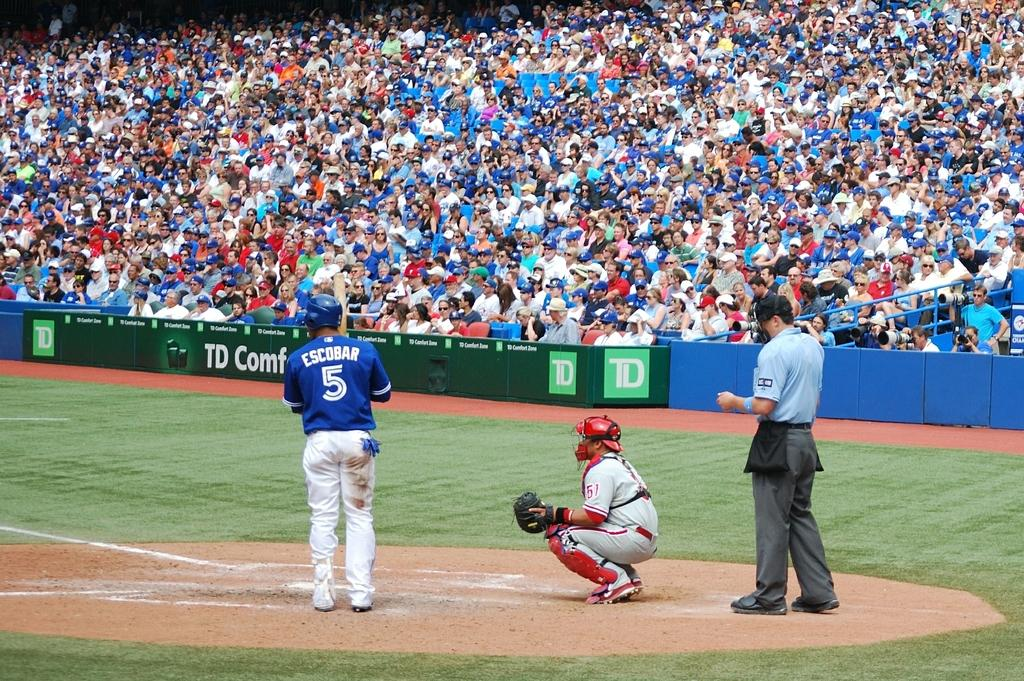<image>
Summarize the visual content of the image. Baseball player number 5 named Escobar is at bat. 